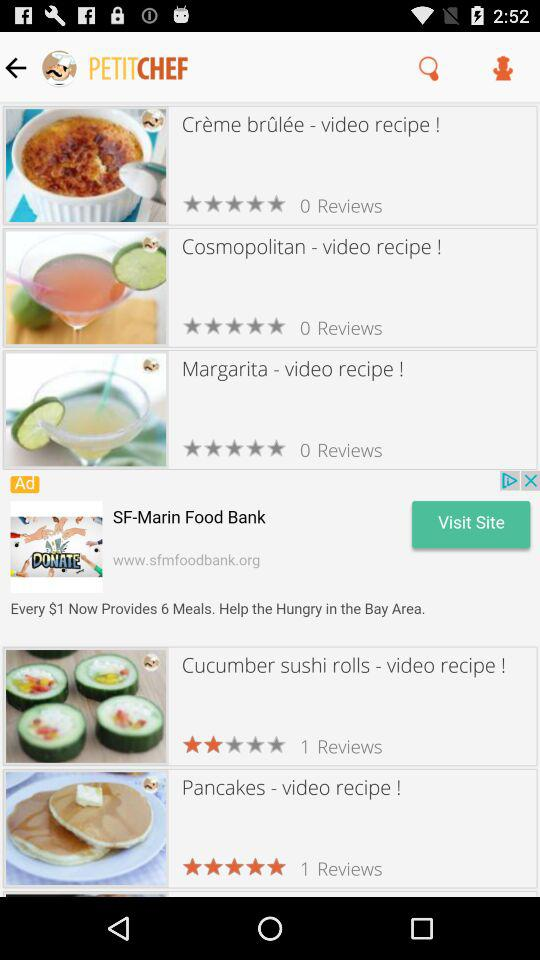How do people like Creme brulee?
When the provided information is insufficient, respond with <no answer>. <no answer> 